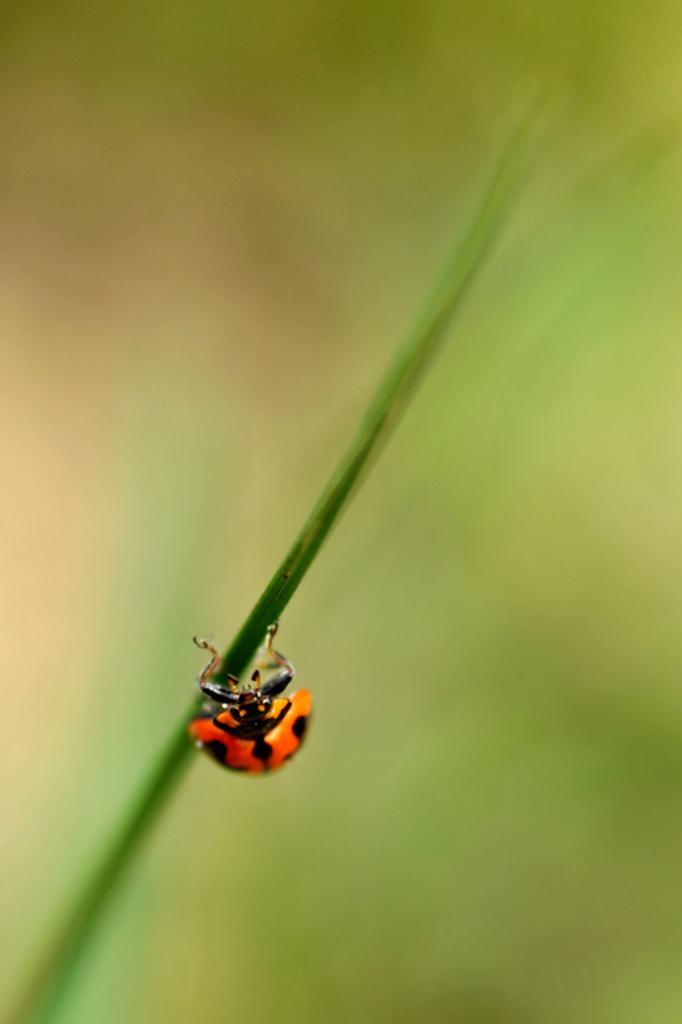What type of creature is in the image? There is an insect in the image. What color is the insect? The insect is red in color. Where is the insect located? The insect is on a plant. What is the color of the background in the image? The background of the image is green. How is the background of the image depicted? The background is blurred. What type of calculator can be seen in the image? There is no calculator present in the image. How does the crow interact with the insect in the image? There is no crow present in the image, so it cannot interact with the insect. 